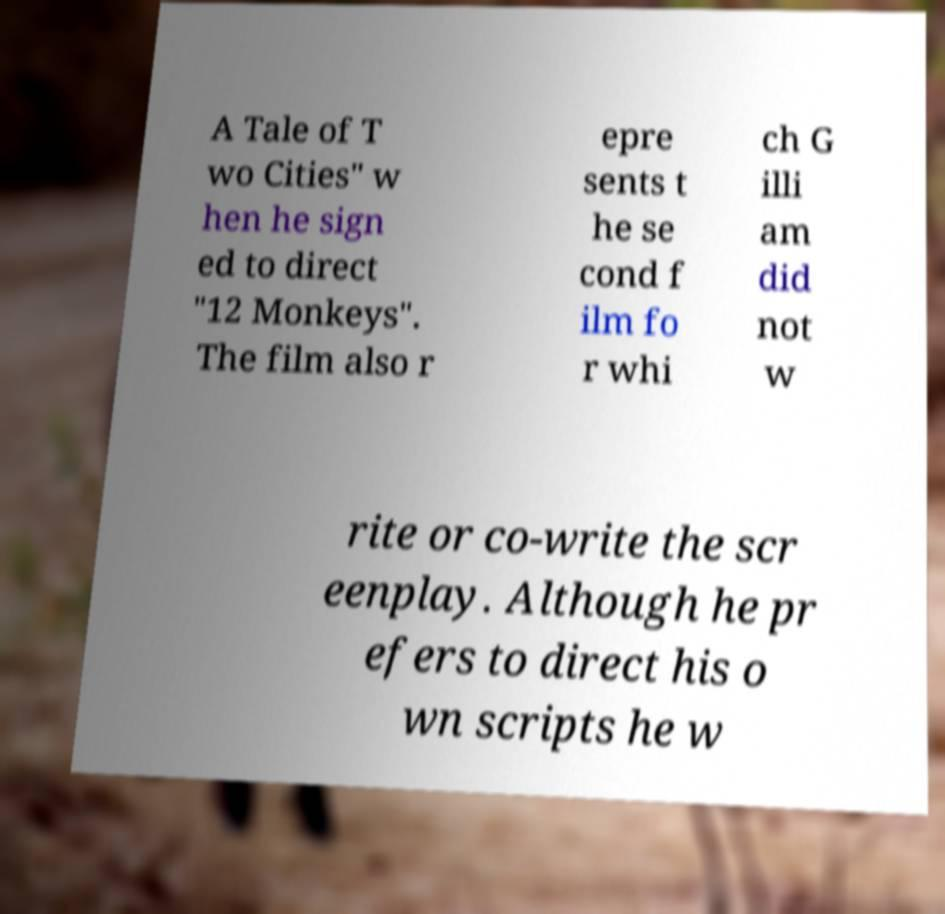Can you read and provide the text displayed in the image?This photo seems to have some interesting text. Can you extract and type it out for me? A Tale of T wo Cities" w hen he sign ed to direct "12 Monkeys". The film also r epre sents t he se cond f ilm fo r whi ch G illi am did not w rite or co-write the scr eenplay. Although he pr efers to direct his o wn scripts he w 